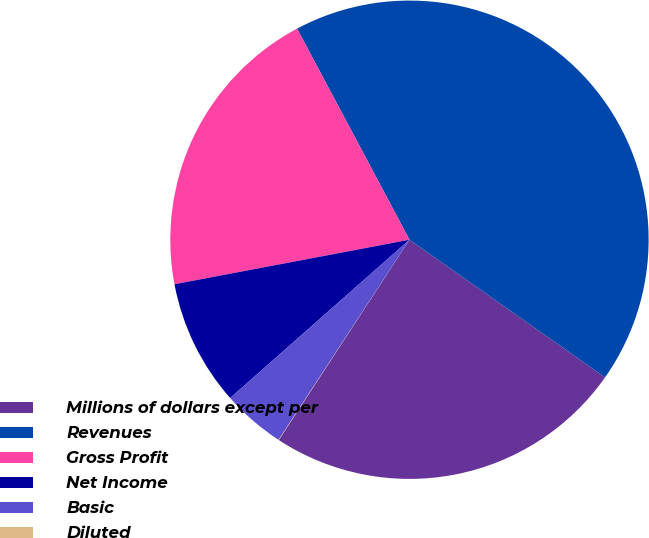Convert chart. <chart><loc_0><loc_0><loc_500><loc_500><pie_chart><fcel>Millions of dollars except per<fcel>Revenues<fcel>Gross Profit<fcel>Net Income<fcel>Basic<fcel>Diluted<nl><fcel>24.44%<fcel>42.55%<fcel>20.19%<fcel>8.53%<fcel>4.27%<fcel>0.02%<nl></chart> 